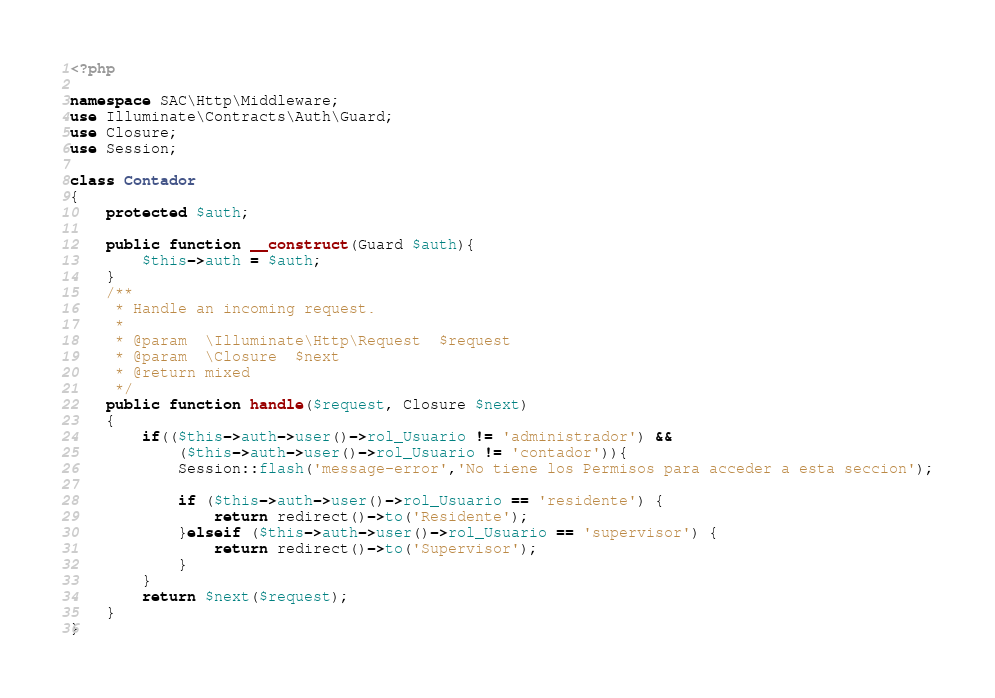<code> <loc_0><loc_0><loc_500><loc_500><_PHP_><?php

namespace SAC\Http\Middleware;
use Illuminate\Contracts\Auth\Guard;
use Closure;
use Session;

class Contador
{
    protected $auth;

    public function __construct(Guard $auth){
        $this->auth = $auth;
    }
    /**
     * Handle an incoming request.
     *
     * @param  \Illuminate\Http\Request  $request
     * @param  \Closure  $next
     * @return mixed
     */
    public function handle($request, Closure $next)
    {
        if(($this->auth->user()->rol_Usuario != 'administrador') && 
            ($this->auth->user()->rol_Usuario != 'contador')){
            Session::flash('message-error','No tiene los Permisos para acceder a esta seccion');

            if ($this->auth->user()->rol_Usuario == 'residente') {
                return redirect()->to('Residente');
            }elseif ($this->auth->user()->rol_Usuario == 'supervisor') {
                return redirect()->to('Supervisor');
            }
        }
        return $next($request);
    }
}
</code> 